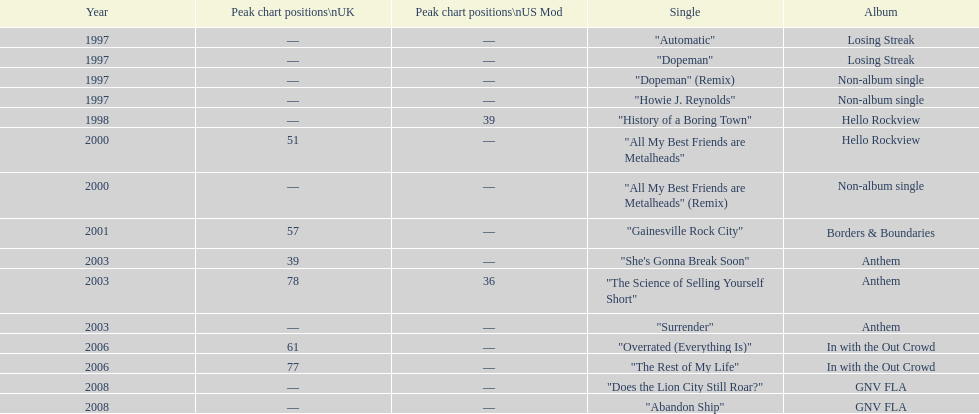What was the next single after "overrated (everything is)"? "The Rest of My Life". 